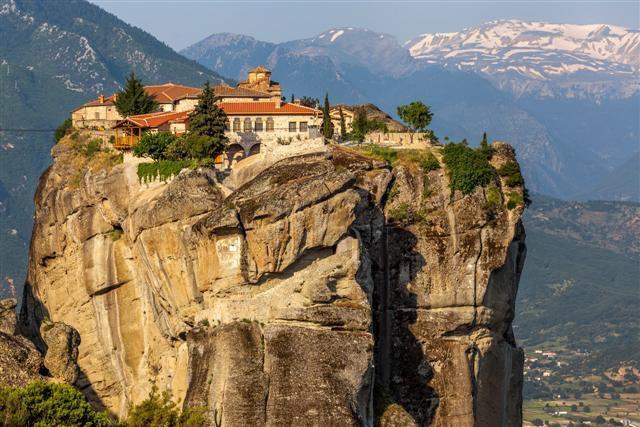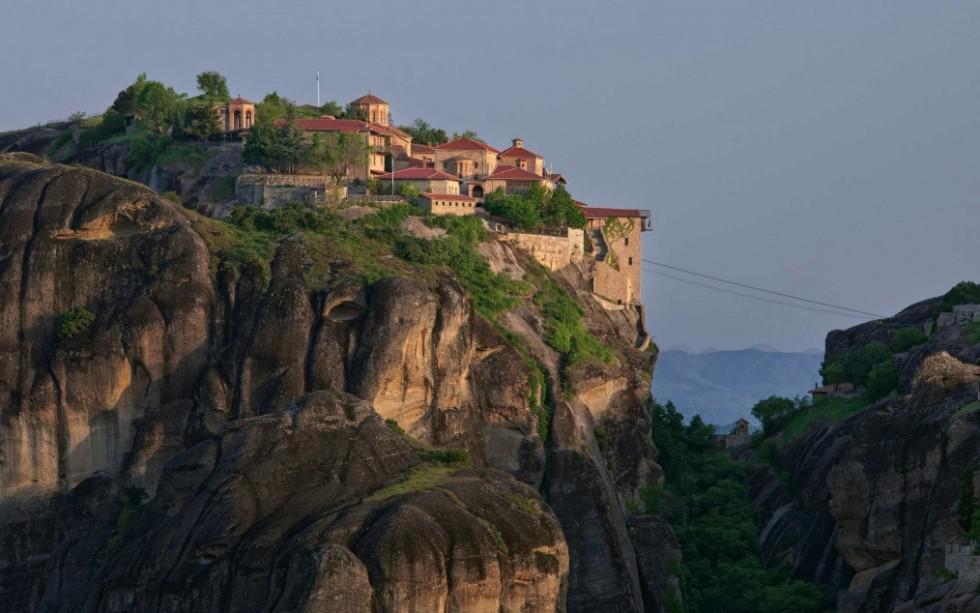The first image is the image on the left, the second image is the image on the right. Given the left and right images, does the statement "Cliffs can be seen behind the castle on the left." hold true? Answer yes or no. No. The first image is the image on the left, the second image is the image on the right. Given the left and right images, does the statement "Terraced steps with greenery lead up to a series of squarish buildings with neutral-colored roofs in one image." hold true? Answer yes or no. No. 